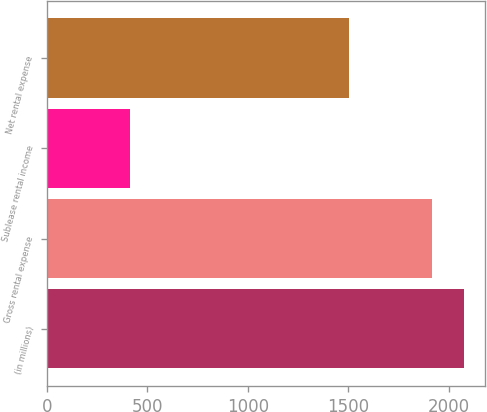<chart> <loc_0><loc_0><loc_500><loc_500><bar_chart><fcel>(in millions)<fcel>Gross rental expense<fcel>Sublease rental income<fcel>Net rental expense<nl><fcel>2076.3<fcel>1917<fcel>415<fcel>1502<nl></chart> 